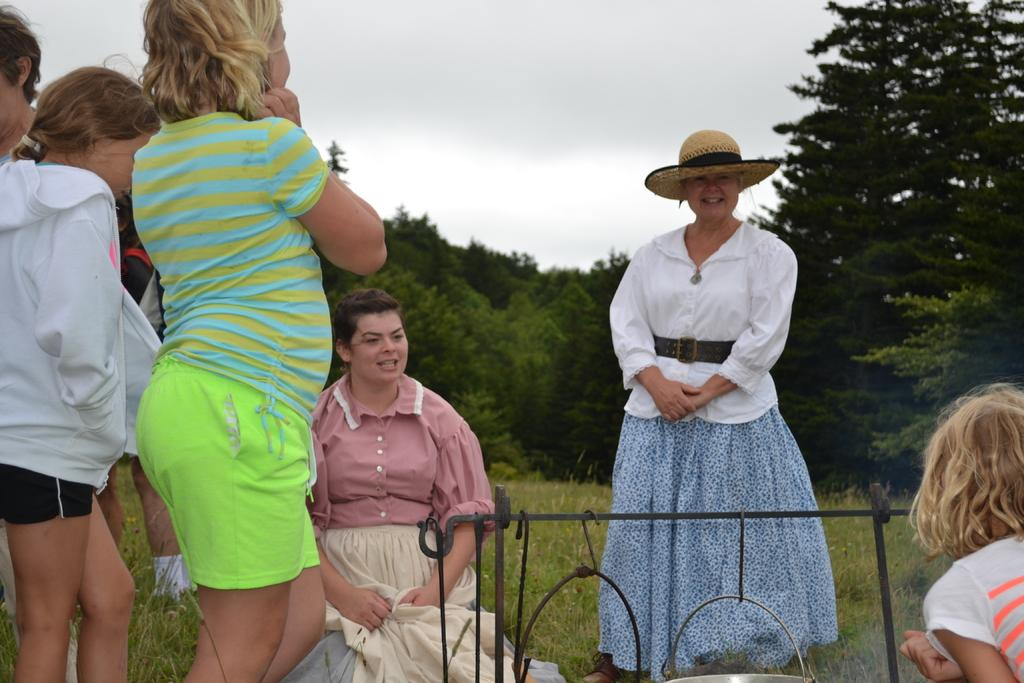Who is present in the image? There are kids and women in the image. What is the setting of the image? They are standing on grassland. What can be seen in the background of the image? There are trees and the sky visible in the background. What is the profit made by the cemetery in the image? There is no cemetery present in the image, so it is not possible to determine any profit made. 